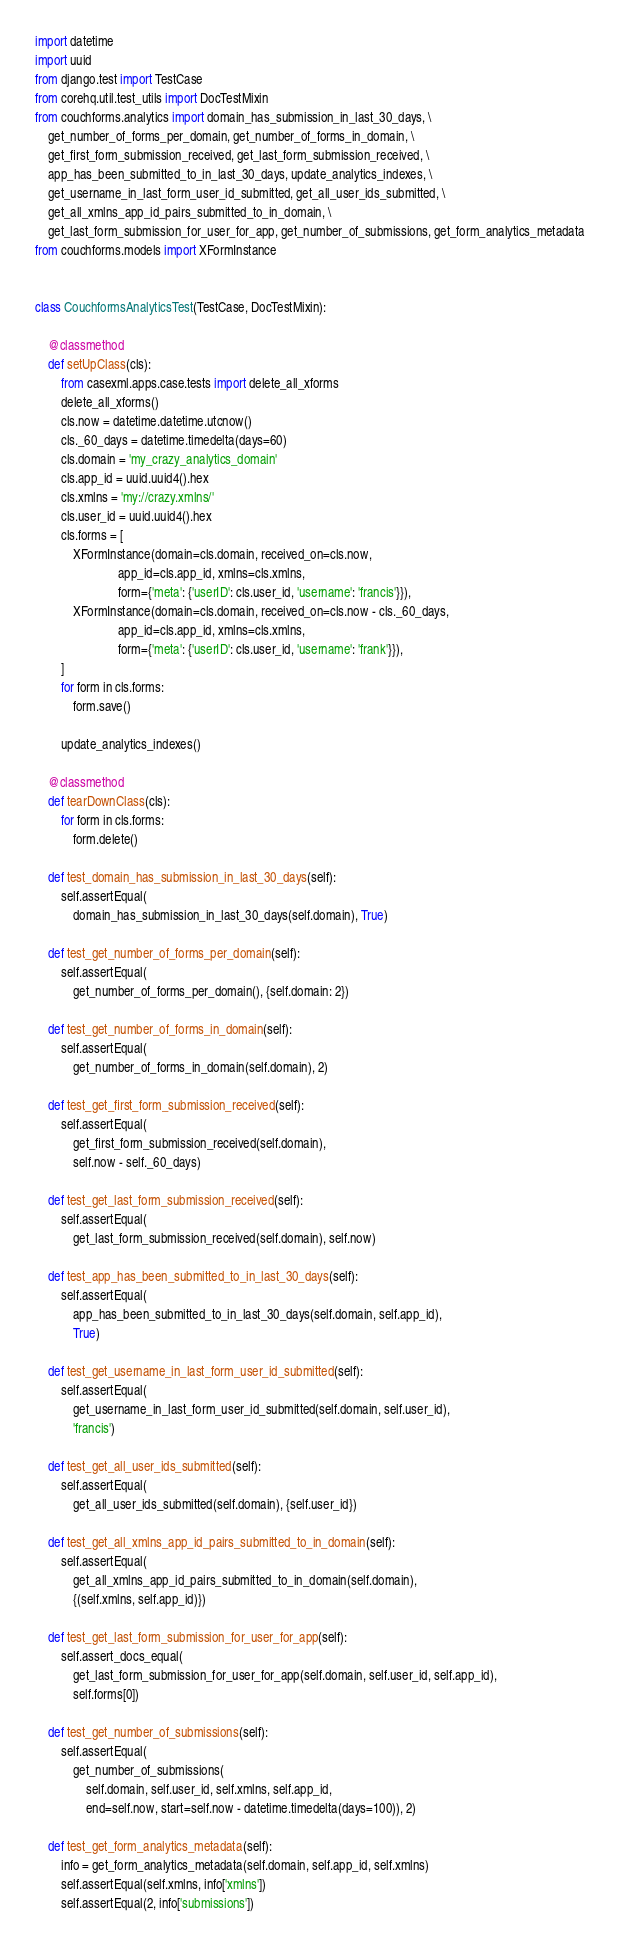<code> <loc_0><loc_0><loc_500><loc_500><_Python_>import datetime
import uuid
from django.test import TestCase
from corehq.util.test_utils import DocTestMixin
from couchforms.analytics import domain_has_submission_in_last_30_days, \
    get_number_of_forms_per_domain, get_number_of_forms_in_domain, \
    get_first_form_submission_received, get_last_form_submission_received, \
    app_has_been_submitted_to_in_last_30_days, update_analytics_indexes, \
    get_username_in_last_form_user_id_submitted, get_all_user_ids_submitted, \
    get_all_xmlns_app_id_pairs_submitted_to_in_domain, \
    get_last_form_submission_for_user_for_app, get_number_of_submissions, get_form_analytics_metadata
from couchforms.models import XFormInstance


class CouchformsAnalyticsTest(TestCase, DocTestMixin):

    @classmethod
    def setUpClass(cls):
        from casexml.apps.case.tests import delete_all_xforms
        delete_all_xforms()
        cls.now = datetime.datetime.utcnow()
        cls._60_days = datetime.timedelta(days=60)
        cls.domain = 'my_crazy_analytics_domain'
        cls.app_id = uuid.uuid4().hex
        cls.xmlns = 'my://crazy.xmlns/'
        cls.user_id = uuid.uuid4().hex
        cls.forms = [
            XFormInstance(domain=cls.domain, received_on=cls.now,
                          app_id=cls.app_id, xmlns=cls.xmlns,
                          form={'meta': {'userID': cls.user_id, 'username': 'francis'}}),
            XFormInstance(domain=cls.domain, received_on=cls.now - cls._60_days,
                          app_id=cls.app_id, xmlns=cls.xmlns,
                          form={'meta': {'userID': cls.user_id, 'username': 'frank'}}),
        ]
        for form in cls.forms:
            form.save()

        update_analytics_indexes()

    @classmethod
    def tearDownClass(cls):
        for form in cls.forms:
            form.delete()

    def test_domain_has_submission_in_last_30_days(self):
        self.assertEqual(
            domain_has_submission_in_last_30_days(self.domain), True)

    def test_get_number_of_forms_per_domain(self):
        self.assertEqual(
            get_number_of_forms_per_domain(), {self.domain: 2})

    def test_get_number_of_forms_in_domain(self):
        self.assertEqual(
            get_number_of_forms_in_domain(self.domain), 2)

    def test_get_first_form_submission_received(self):
        self.assertEqual(
            get_first_form_submission_received(self.domain),
            self.now - self._60_days)

    def test_get_last_form_submission_received(self):
        self.assertEqual(
            get_last_form_submission_received(self.domain), self.now)

    def test_app_has_been_submitted_to_in_last_30_days(self):
        self.assertEqual(
            app_has_been_submitted_to_in_last_30_days(self.domain, self.app_id),
            True)

    def test_get_username_in_last_form_user_id_submitted(self):
        self.assertEqual(
            get_username_in_last_form_user_id_submitted(self.domain, self.user_id),
            'francis')

    def test_get_all_user_ids_submitted(self):
        self.assertEqual(
            get_all_user_ids_submitted(self.domain), {self.user_id})

    def test_get_all_xmlns_app_id_pairs_submitted_to_in_domain(self):
        self.assertEqual(
            get_all_xmlns_app_id_pairs_submitted_to_in_domain(self.domain),
            {(self.xmlns, self.app_id)})

    def test_get_last_form_submission_for_user_for_app(self):
        self.assert_docs_equal(
            get_last_form_submission_for_user_for_app(self.domain, self.user_id, self.app_id),
            self.forms[0])

    def test_get_number_of_submissions(self):
        self.assertEqual(
            get_number_of_submissions(
                self.domain, self.user_id, self.xmlns, self.app_id,
                end=self.now, start=self.now - datetime.timedelta(days=100)), 2)

    def test_get_form_analytics_metadata(self):
        info = get_form_analytics_metadata(self.domain, self.app_id, self.xmlns)
        self.assertEqual(self.xmlns, info['xmlns'])
        self.assertEqual(2, info['submissions'])
</code> 